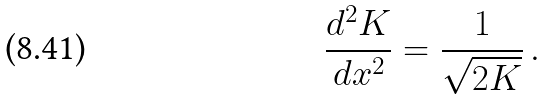<formula> <loc_0><loc_0><loc_500><loc_500>\frac { d ^ { 2 } K } { d x ^ { 2 } } = \frac { 1 } { \sqrt { 2 K } } \, .</formula> 